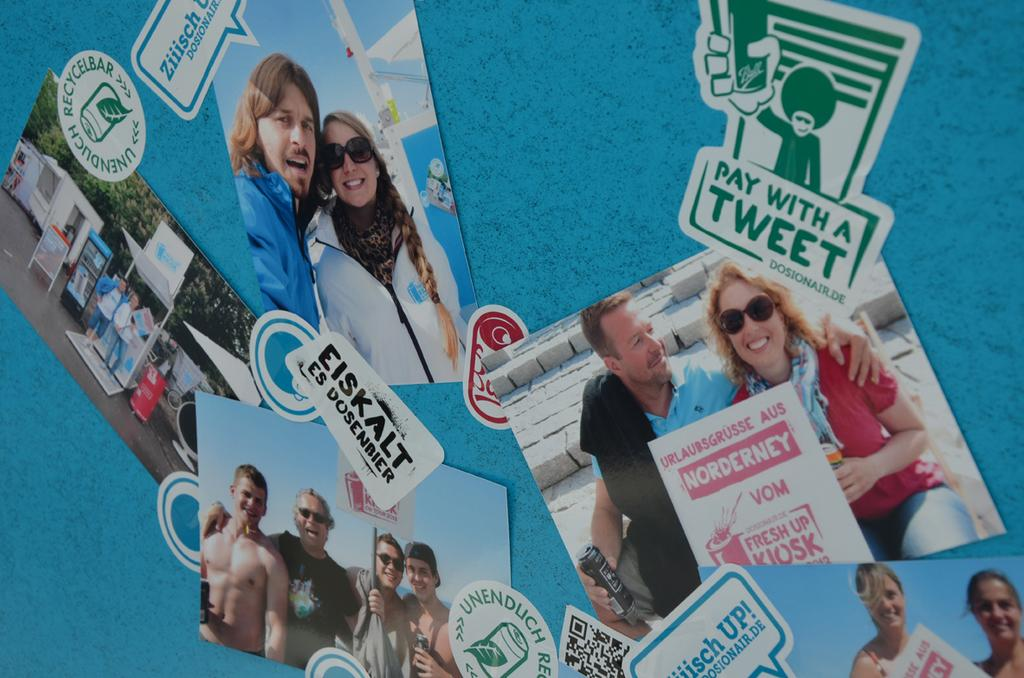What can be seen on the wall in the image? There are posts on a wall in the image. Can you describe the setting of the image? The image is likely taken in a room or an enclosed space. What type of health benefits can be gained from the quilt in the image? There is no quilt present in the image, so it is not possible to determine any health benefits. 